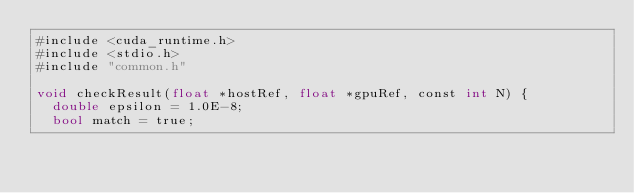<code> <loc_0><loc_0><loc_500><loc_500><_Cuda_>#include <cuda_runtime.h>
#include <stdio.h>
#include "common.h"

void checkResult(float *hostRef, float *gpuRef, const int N) {
  double epsilon = 1.0E-8;
  bool match = true;</code> 